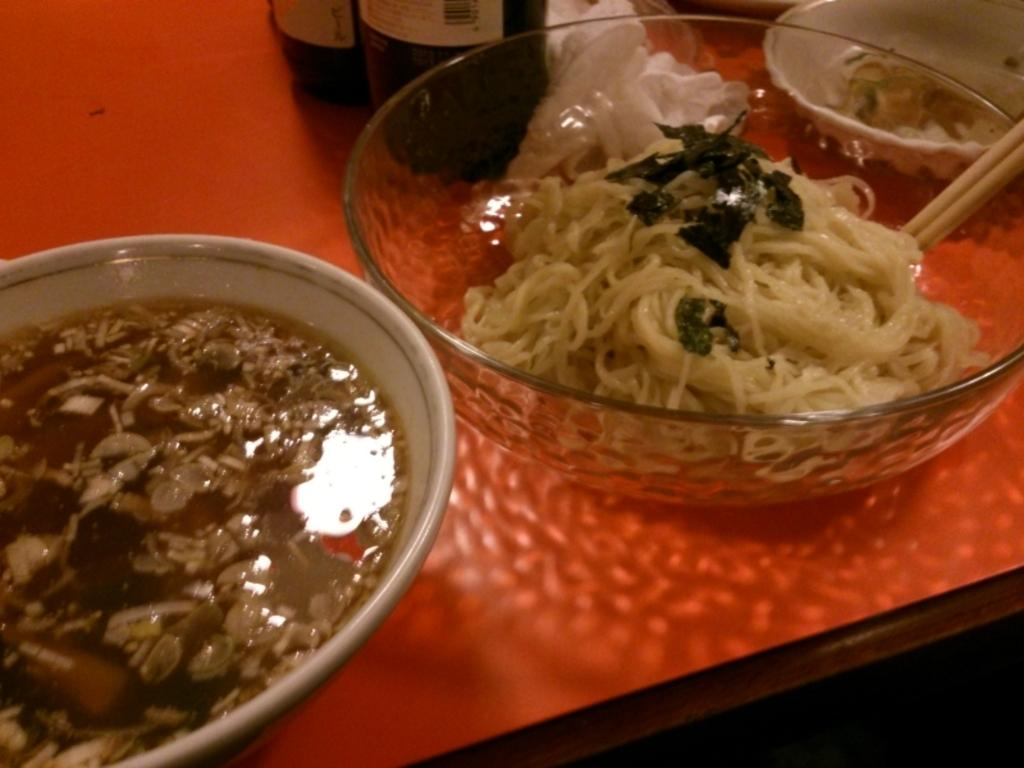How many bowls are visible in the image? There are three bowls in the image. What is inside the bowls? The bowls contain food. Where are the bowls located? The bowls are on a table. What else can be seen on the table besides the bowls? There are two bottles in the image. What invention is being taught in the image? There is no invention or teaching depicted in the image; it simply shows three bowls containing food on a table with two bottles. 